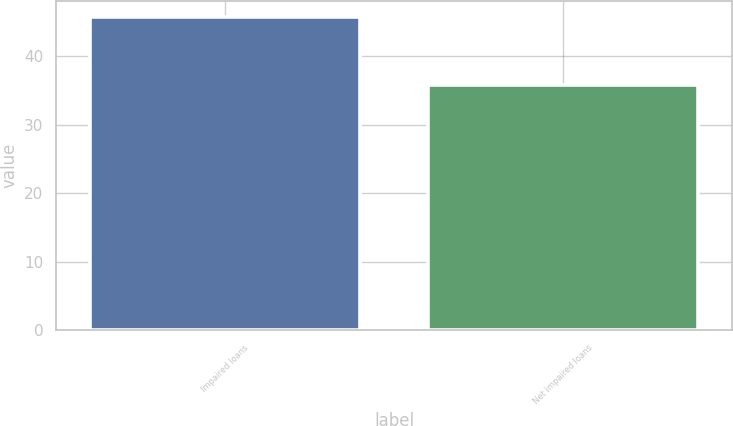Convert chart to OTSL. <chart><loc_0><loc_0><loc_500><loc_500><bar_chart><fcel>Impaired loans<fcel>Net impaired loans<nl><fcel>45.8<fcel>35.8<nl></chart> 